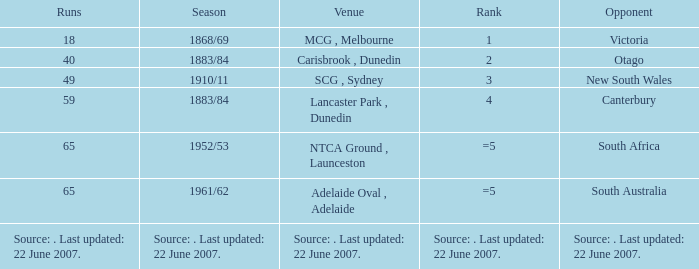Which Runs has a Rank of =5 and an Opponent of south australia? 65.0. 